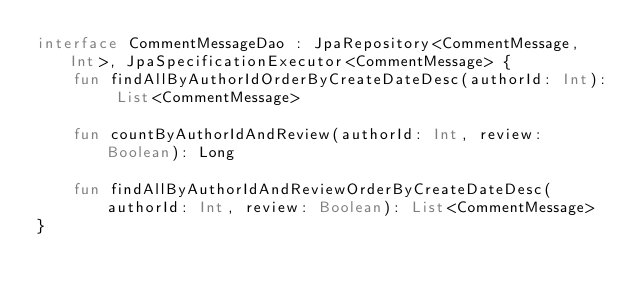Convert code to text. <code><loc_0><loc_0><loc_500><loc_500><_Kotlin_>interface CommentMessageDao : JpaRepository<CommentMessage, Int>, JpaSpecificationExecutor<CommentMessage> {
    fun findAllByAuthorIdOrderByCreateDateDesc(authorId: Int): List<CommentMessage>

    fun countByAuthorIdAndReview(authorId: Int, review: Boolean): Long

    fun findAllByAuthorIdAndReviewOrderByCreateDateDesc(authorId: Int, review: Boolean): List<CommentMessage>
}</code> 